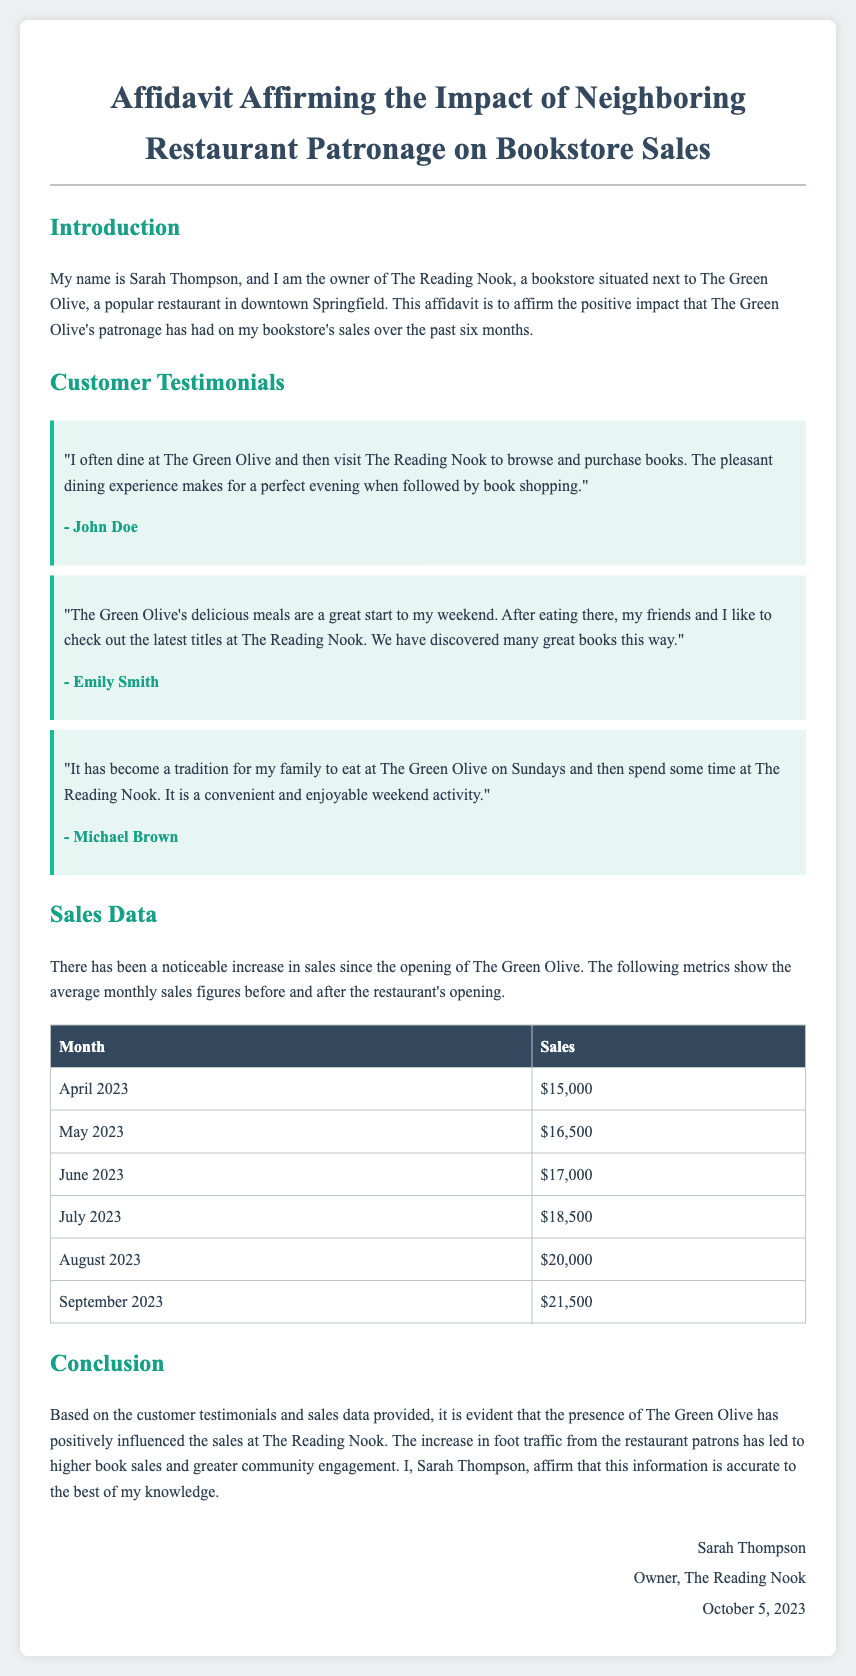What is the name of the bookstore owner? The affidavit states that the owner of the bookstore is named Sarah Thompson.
Answer: Sarah Thompson What is the name of the neighboring restaurant? The document mentions that the name of the neighboring restaurant is The Green Olive.
Answer: The Green Olive In which month was the highest sales recorded? The sales data table indicates the highest sales in September 2023.
Answer: September 2023 How many testimonials are included in the affidavit? The document lists three customer testimonials provided in the section about customer testimonials.
Answer: Three What was the average sales amount in June 2023? The sales data for June 2023 shows an average sales amount of $17,000.
Answer: $17,000 What trend is observed in the bookstore sales after the restaurant opened? The affidavit describes that there is a noticeable increase in sales after the opening of The Green Olive.
Answer: Increase What activity do families often do after dining at The Green Olive? According to a testimonial, families often spend time at The Reading Nook after dining at The Green Olive.
Answer: Spend time at The Reading Nook What is the document’s purpose? The affidavit's purpose is to affirm the impact of restaurant patronage on bookstore sales.
Answer: Affirm the impact of restaurant patronage on bookstore sales 